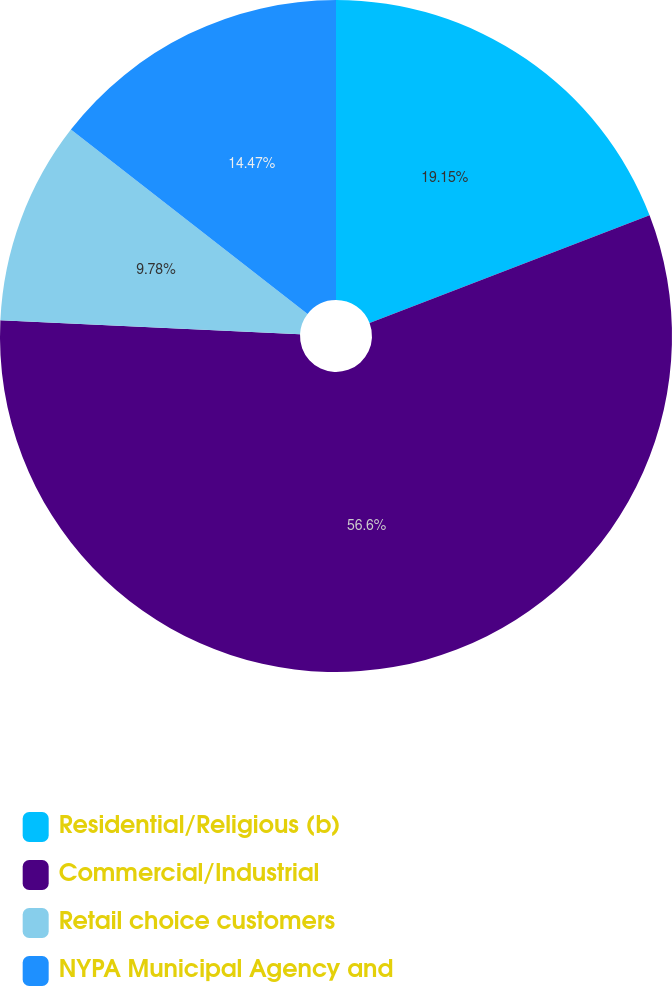Convert chart. <chart><loc_0><loc_0><loc_500><loc_500><pie_chart><fcel>Residential/Religious (b)<fcel>Commercial/Industrial<fcel>Retail choice customers<fcel>NYPA Municipal Agency and<nl><fcel>19.15%<fcel>56.6%<fcel>9.78%<fcel>14.47%<nl></chart> 